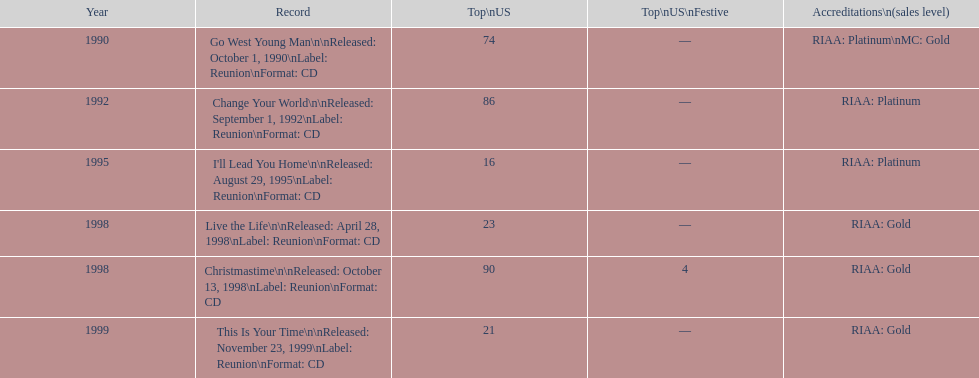How many songs are listed from 1998? 2. Give me the full table as a dictionary. {'header': ['Year', 'Record', 'Top\\nUS', 'Top\\nUS\\nFestive', 'Accreditations\\n(sales level)'], 'rows': [['1990', 'Go West Young Man\\n\\nReleased: October 1, 1990\\nLabel: Reunion\\nFormat: CD', '74', '—', 'RIAA: Platinum\\nMC: Gold'], ['1992', 'Change Your World\\n\\nReleased: September 1, 1992\\nLabel: Reunion\\nFormat: CD', '86', '—', 'RIAA: Platinum'], ['1995', "I'll Lead You Home\\n\\nReleased: August 29, 1995\\nLabel: Reunion\\nFormat: CD", '16', '—', 'RIAA: Platinum'], ['1998', 'Live the Life\\n\\nReleased: April 28, 1998\\nLabel: Reunion\\nFormat: CD', '23', '—', 'RIAA: Gold'], ['1998', 'Christmastime\\n\\nReleased: October 13, 1998\\nLabel: Reunion\\nFormat: CD', '90', '4', 'RIAA: Gold'], ['1999', 'This Is Your Time\\n\\nReleased: November 23, 1999\\nLabel: Reunion\\nFormat: CD', '21', '—', 'RIAA: Gold']]} 